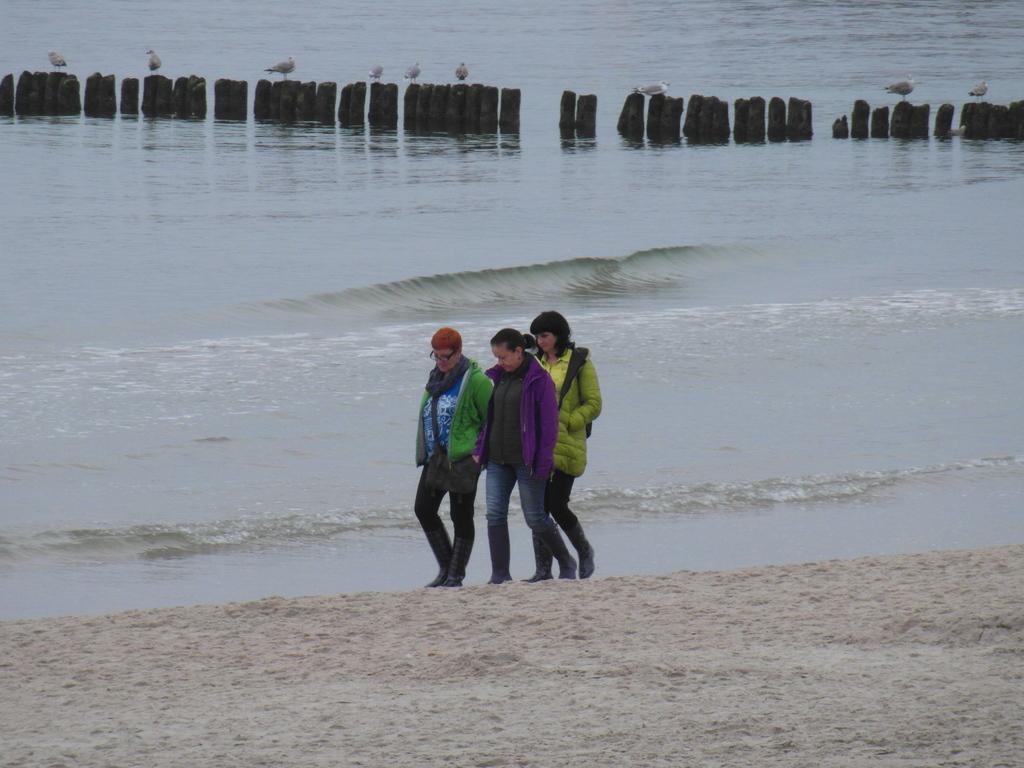Could you give a brief overview of what you see in this image? In this image we can see a group of people walking on the ground. One woman is wearing a green jacket and spectacles. In the background, we can see a group of poles on which birds are standing on them and water. 